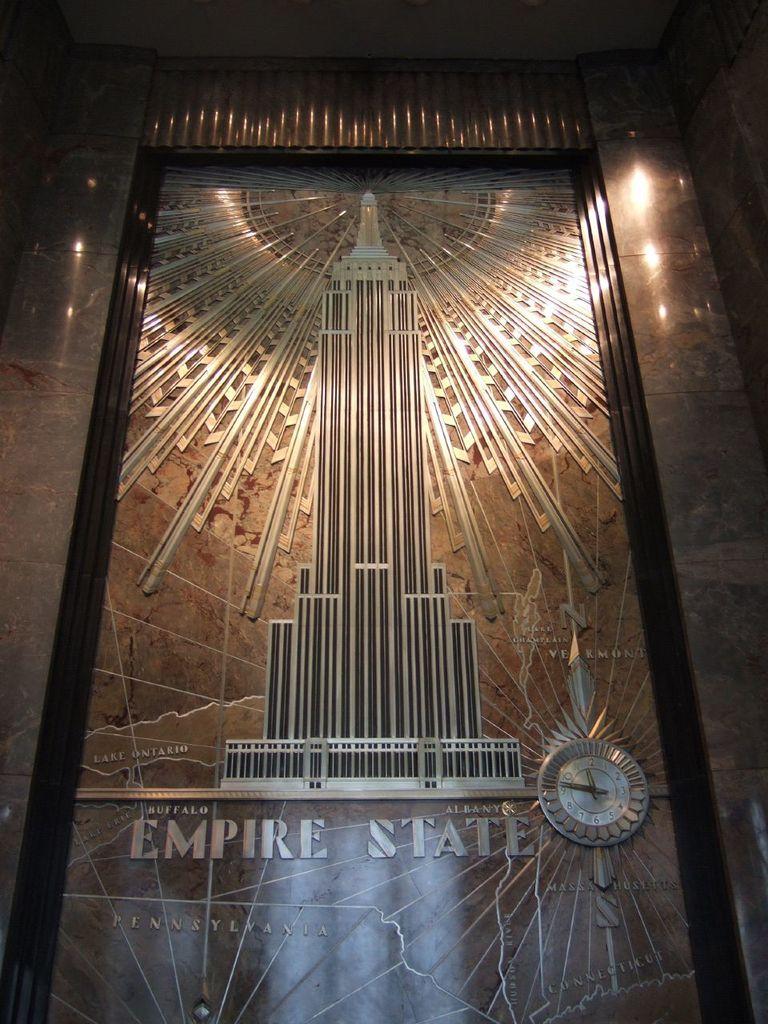Is lake ontario in the background?
Keep it short and to the point. No. 